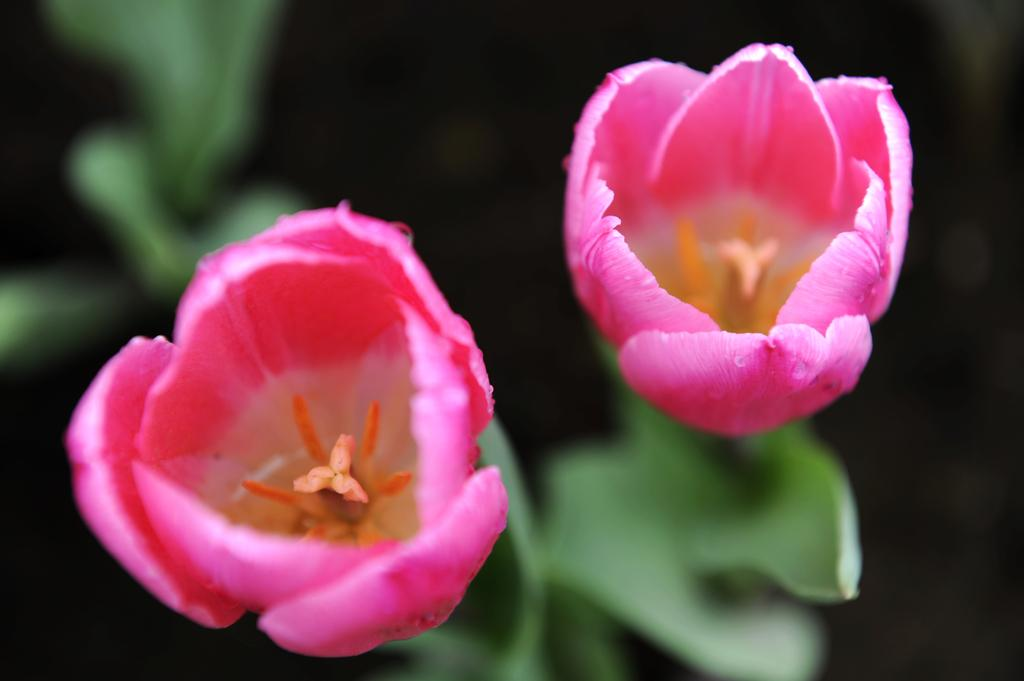What type of vegetation can be seen on the right side of the image? There are flowers on the right side of the image. What type of vegetation can be seen on the left side of the image? There are flowers on the left side of the image. What color are the flowers in the image? The flowers are pink in color. What is the cause of the sky's color in the image? The image does not depict the sky, so there is no information about the sky's color or its cause. 